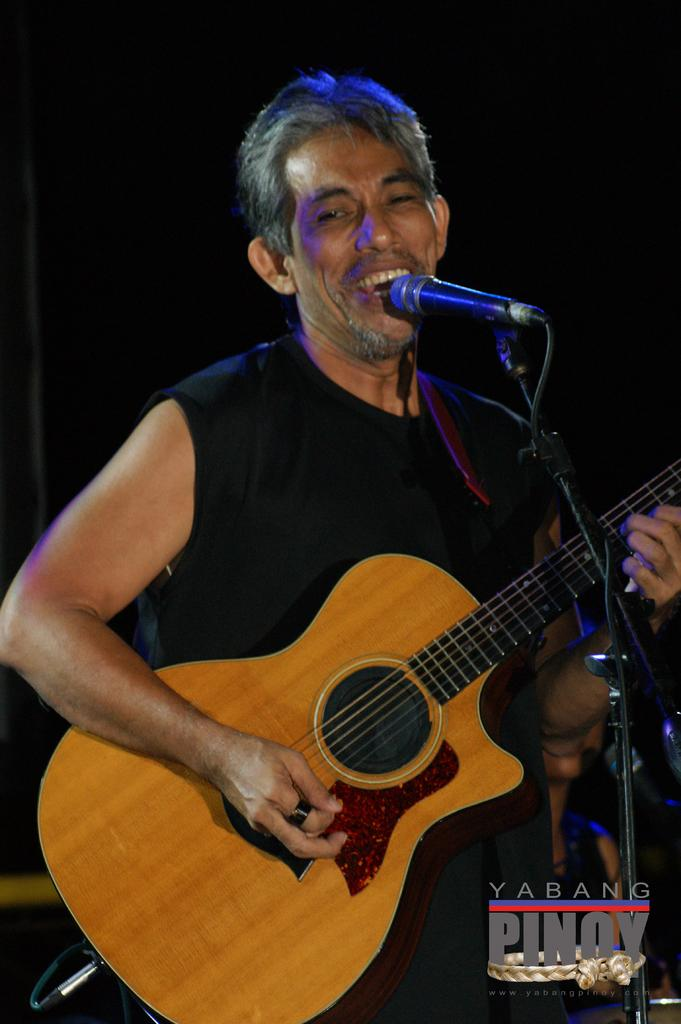What is the main subject of the image? The main subject of the image is a man. What is the man holding in his hand? The man is holding a guitar in his hand. What type of hammer is the man using to play the guitar in the image? There is no hammer present in the image; the man is holding a guitar. What type of rake is the man using to accompany his guitar playing in the image? There is no rake present in the image; the man is holding a guitar. 